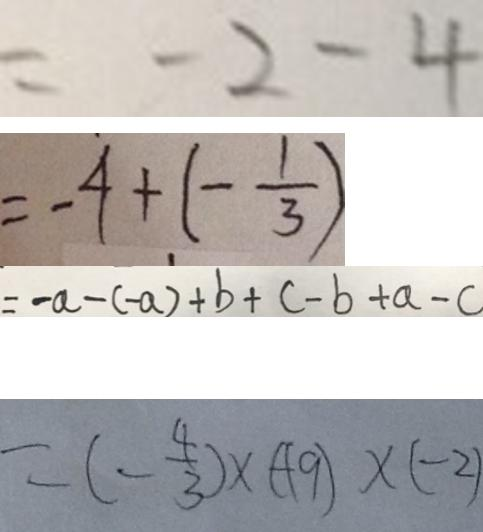<formula> <loc_0><loc_0><loc_500><loc_500>= - 2 - 4 
 = - 4 + ( - \frac { 1 } { 3 } ) 
 = - a - ( - a ) + b + c - b + a - c 
 = ( - \frac { 4 } { 3 } ) \times ( + 9 ) \times ( - 2 )</formula> 